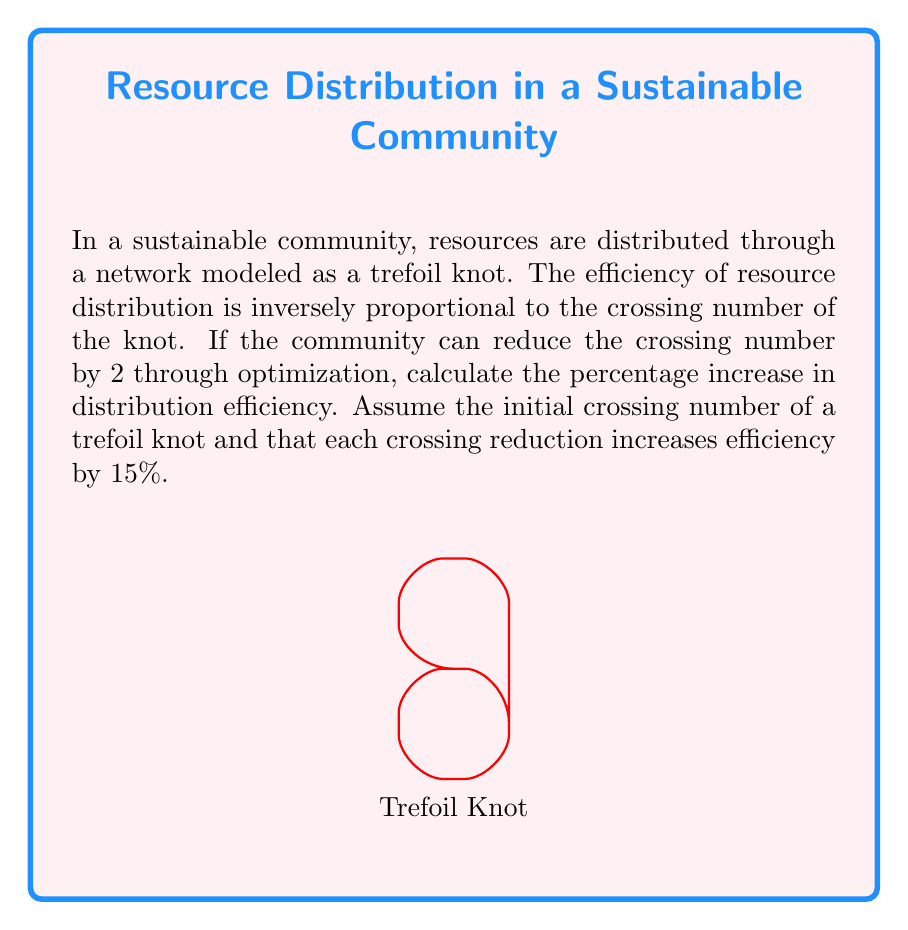Can you solve this math problem? Let's approach this step-by-step:

1) First, recall that a trefoil knot has a crossing number of 3. This is our starting point.

2) The community can reduce the crossing number by 2, so the final crossing number will be:
   $3 - 2 = 1$

3) We're told that each crossing reduction increases efficiency by 15%. With 2 reductions, the total efficiency increase is:
   $2 * 15\% = 30\%$

4) To calculate the percentage increase in efficiency, we use the formula:

   $\text{Percentage Increase} = \frac{\text{Increase}}{\text{Original}} * 100\%$

5) In this case, the increase is 30% of the original efficiency. So:

   $\text{Percentage Increase} = \frac{30\%}{100\%} * 100\% = 30\%$

Therefore, the distribution efficiency will increase by 30%.
Answer: 30% 